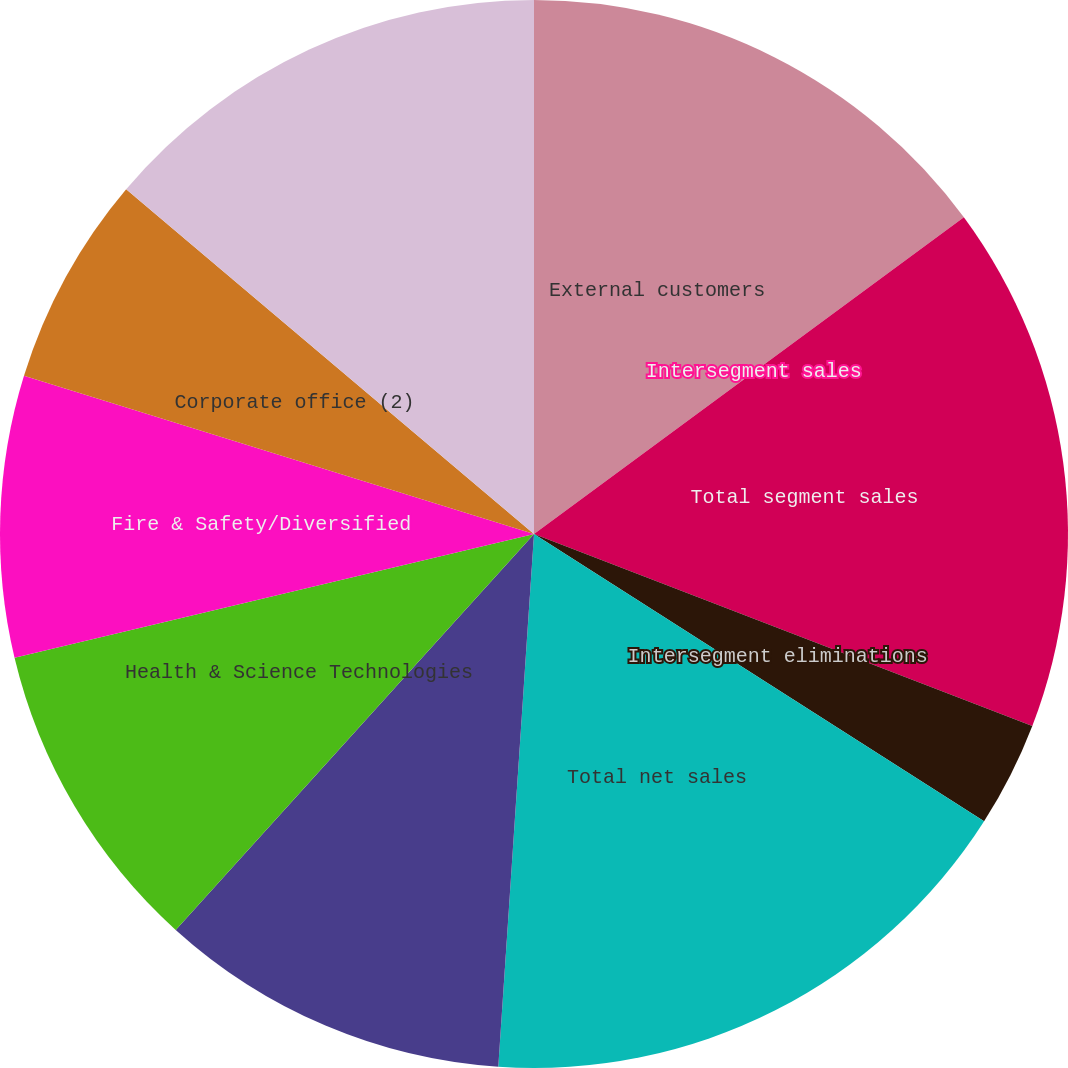Convert chart. <chart><loc_0><loc_0><loc_500><loc_500><pie_chart><fcel>External customers<fcel>Intersegment sales<fcel>Total segment sales<fcel>Intersegment eliminations<fcel>Total net sales<fcel>Fluid & Metering Technologies<fcel>Health & Science Technologies<fcel>Fire & Safety/Diversified<fcel>Corporate office (2)<fcel>Total operating income<nl><fcel>14.89%<fcel>0.0%<fcel>15.96%<fcel>3.19%<fcel>17.02%<fcel>10.64%<fcel>9.57%<fcel>8.51%<fcel>6.38%<fcel>13.83%<nl></chart> 